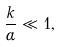Convert formula to latex. <formula><loc_0><loc_0><loc_500><loc_500>\frac { k } { \alpha } \ll 1 ,</formula> 